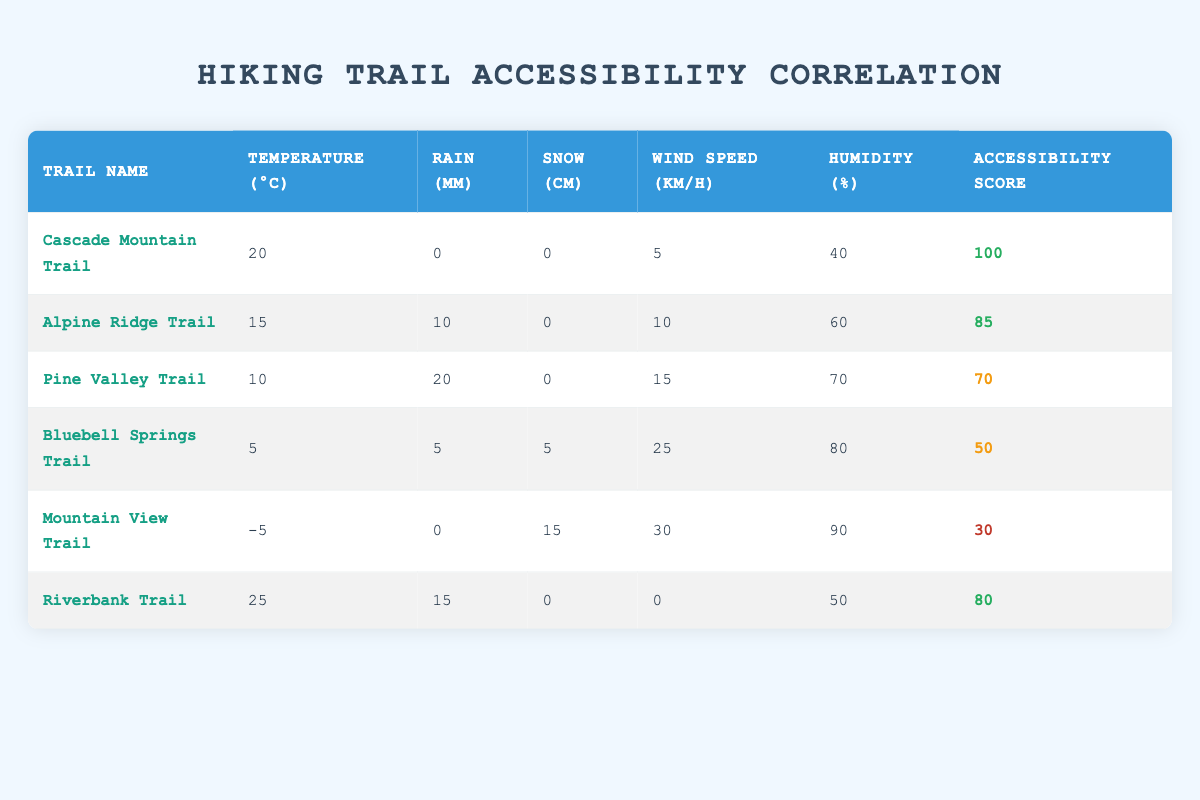What is the accessibility score for the Cascade Mountain Trail? The accessibility score for the Cascade Mountain Trail is listed in the table under the "Accessibility Score" column, which shows a score of 100.
Answer: 100 Which trail experienced the most rain (in mm)? Referring to the "Rain (mm)" column, Pine Valley Trail has the highest value of 20 mm, which is greater than the values for all other trails.
Answer: Pine Valley Trail True or False: Bluebell Springs Trail has an accessibility score greater than 60. By checking the "Accessibility Score" for Bluebell Springs Trail, it shows a score of 50, which is less than 60, making the statement false.
Answer: False What is the relationship between wind speed and trail accessibility score? Analyzing the "Wind Speed (km/h)" and "Accessibility Score" columns, it seems that lower wind speeds (like 0 km/h for Riverbank Trail) can coexist with higher accessibility scores (80), while higher wind speeds (like 30 km/h for Mountain View Trail) have lower accessibility (30). However, this doesn't establish a clear linear relationship, as accessibility still varies with rain and snow.
Answer: Inconclusive relationship Calculate the average temperature of the trails listed. To find the average temperature, sum the values from the "Temperature (°C)" column: (20 + 15 + 10 + 5 - 5 + 25) = 70. Dividing by the number of trails (6), the average temperature is 70/6 = 11.67°C.
Answer: 11.67 How many trails have an accessibility score of 80 or higher? Reviewing the "Accessibility Score" column: Cascade Mountain Trail (100), Alpine Ridge Trail (85), and Riverbank Trail (80) each score 80 or higher, totaling three trails.
Answer: 3 Is there a trail that had snow accumulation but still maintained a high accessibility score? The only trail with snow is Mountain View Trail (15 cm), which has a low accessibility score of 30, while Bluebell Springs Trail had 5 cm of snow but a score of 50, making the implication that trails with snow do not maintain high accessibility scores.
Answer: No What is the maximum temperature recorded among these trails? The maximum temperature can be found in the "Temperature (°C)" column, which shows that Riverbank Trail tops at 25°C, more than any other trails.
Answer: 25 